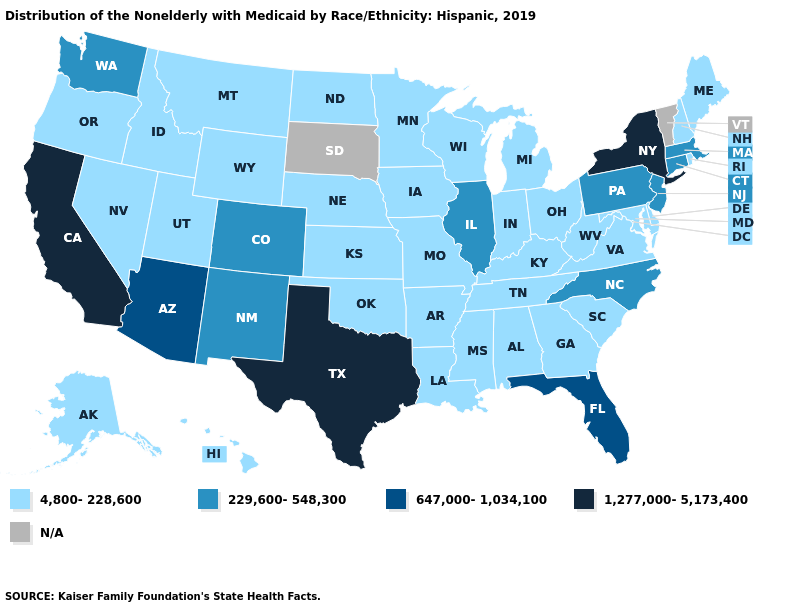What is the value of California?
Concise answer only. 1,277,000-5,173,400. Which states have the lowest value in the MidWest?
Answer briefly. Indiana, Iowa, Kansas, Michigan, Minnesota, Missouri, Nebraska, North Dakota, Ohio, Wisconsin. Does Texas have the lowest value in the USA?
Give a very brief answer. No. Does California have the highest value in the West?
Concise answer only. Yes. Which states have the highest value in the USA?
Short answer required. California, New York, Texas. Name the states that have a value in the range 4,800-228,600?
Concise answer only. Alabama, Alaska, Arkansas, Delaware, Georgia, Hawaii, Idaho, Indiana, Iowa, Kansas, Kentucky, Louisiana, Maine, Maryland, Michigan, Minnesota, Mississippi, Missouri, Montana, Nebraska, Nevada, New Hampshire, North Dakota, Ohio, Oklahoma, Oregon, Rhode Island, South Carolina, Tennessee, Utah, Virginia, West Virginia, Wisconsin, Wyoming. What is the lowest value in the USA?
Keep it brief. 4,800-228,600. What is the value of Alaska?
Write a very short answer. 4,800-228,600. What is the value of California?
Concise answer only. 1,277,000-5,173,400. Name the states that have a value in the range 647,000-1,034,100?
Be succinct. Arizona, Florida. What is the value of Arizona?
Keep it brief. 647,000-1,034,100. Which states have the highest value in the USA?
Be succinct. California, New York, Texas. Does New York have the highest value in the USA?
Write a very short answer. Yes. Does the map have missing data?
Write a very short answer. Yes. 